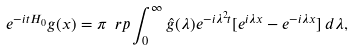<formula> <loc_0><loc_0><loc_500><loc_500>e ^ { - i t H _ { 0 } } g ( x ) = \pi \ r p \int _ { 0 } ^ { \infty } \hat { g } ( \lambda ) e ^ { - i \lambda ^ { 2 } t } [ e ^ { i \lambda x } - e ^ { - i \lambda x } ] \, d \lambda ,</formula> 